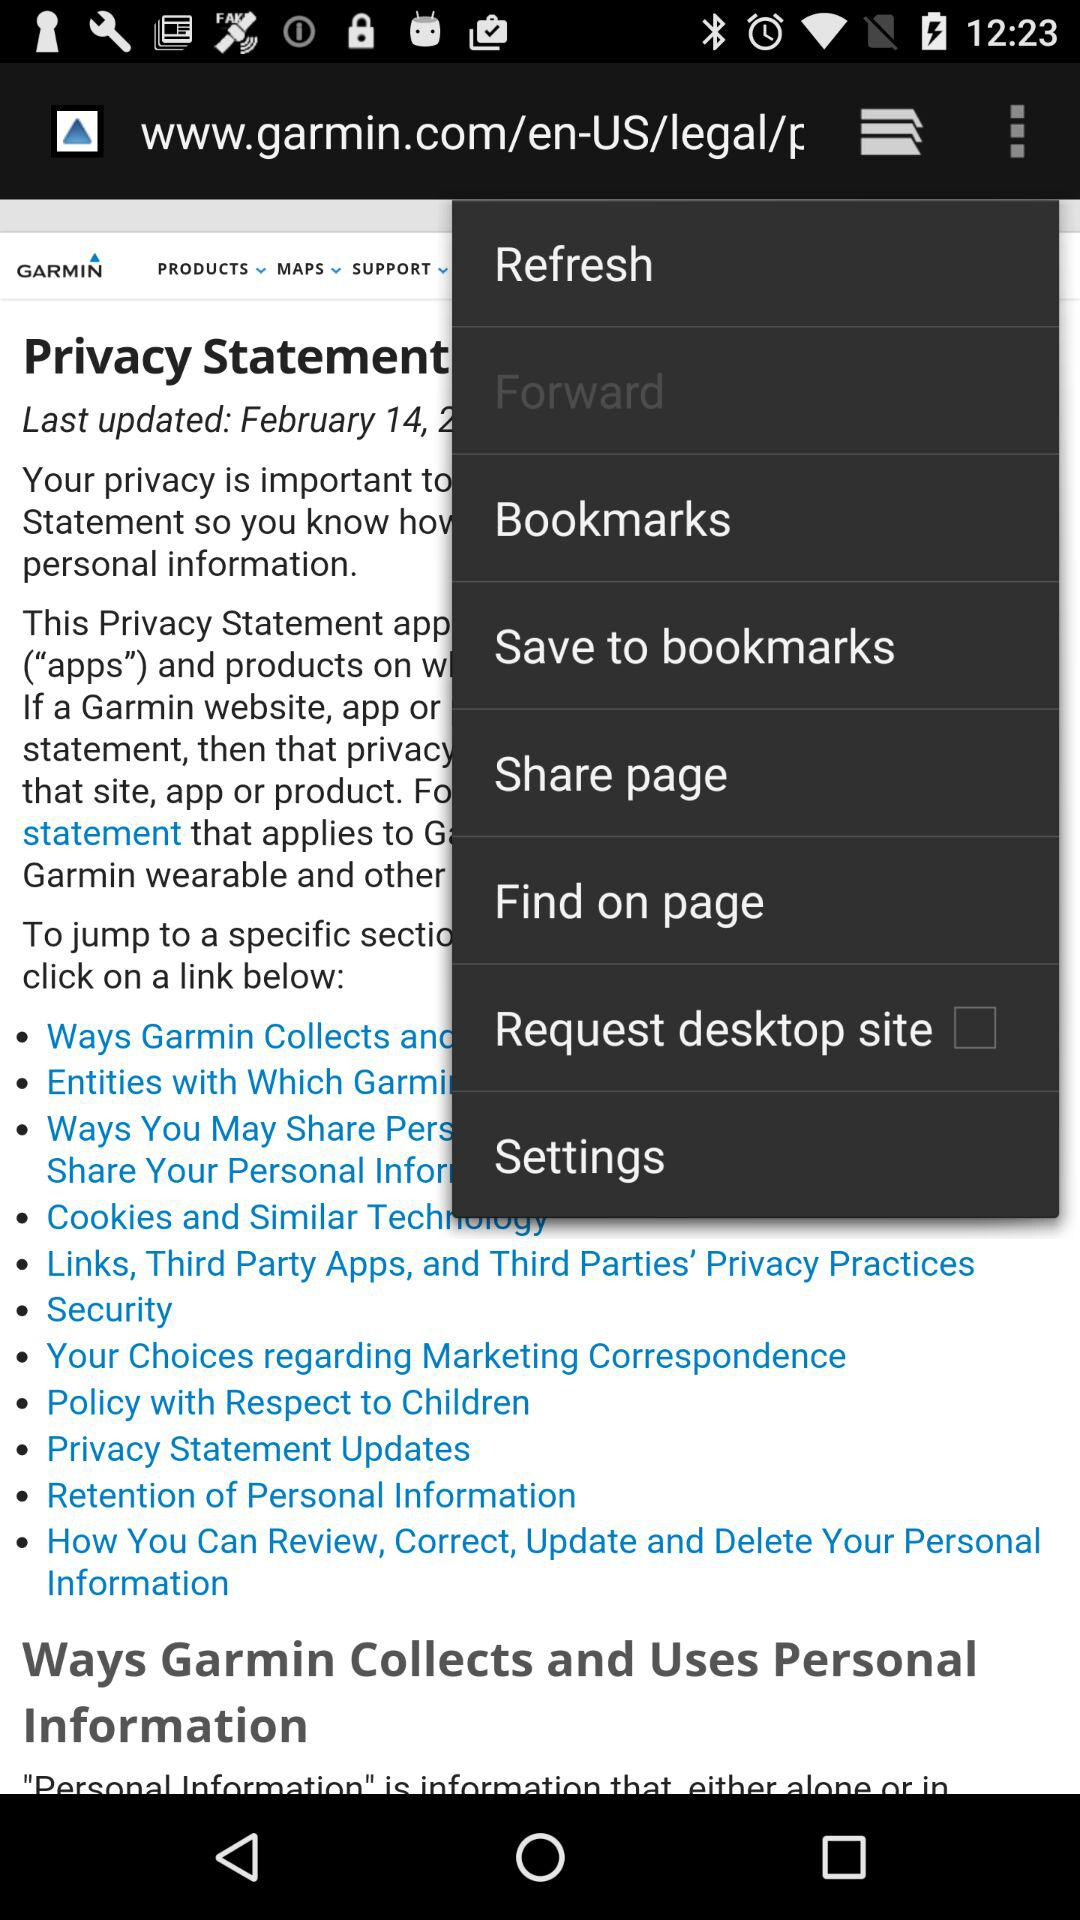What is the status of "Request desktop site"? The status is "off". 